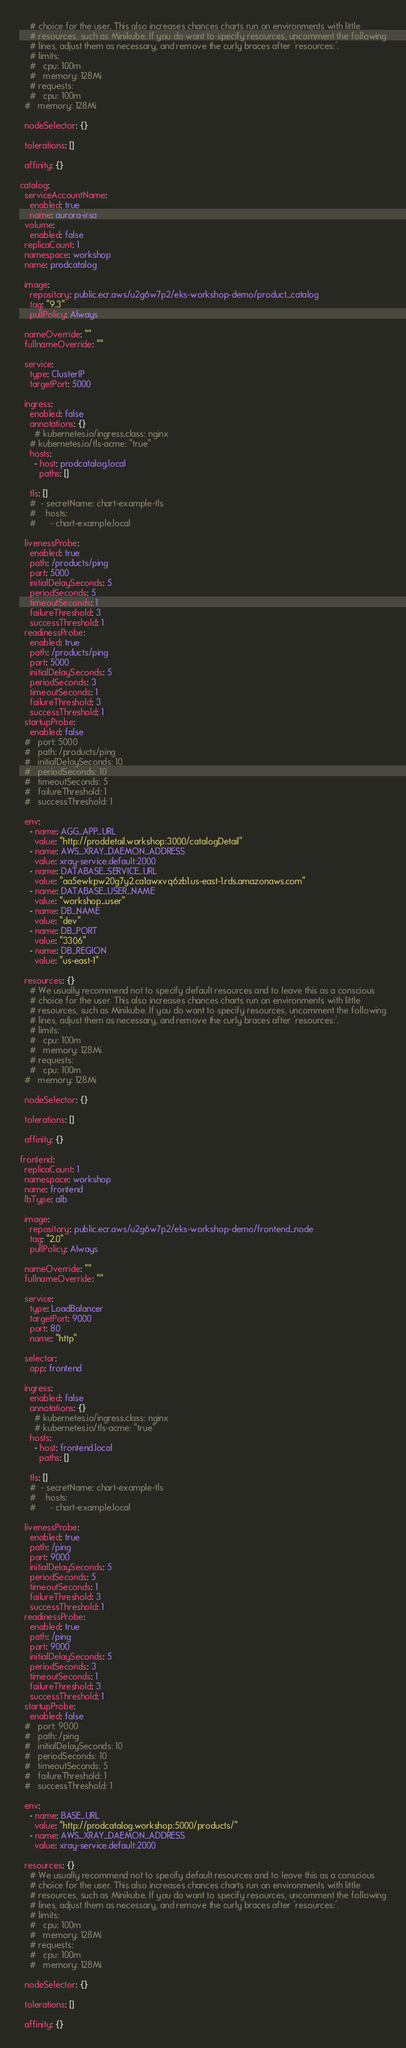<code> <loc_0><loc_0><loc_500><loc_500><_YAML_>    # choice for the user. This also increases chances charts run on environments with little
    # resources, such as Minikube. If you do want to specify resources, uncomment the following
    # lines, adjust them as necessary, and remove the curly braces after 'resources:'.
    # limits:
    #   cpu: 100m
    #   memory: 128Mi
    # requests:
    #   cpu: 100m
  #   memory: 128Mi

  nodeSelector: {}

  tolerations: []

  affinity: {}
  
catalog:
  serviceAccountName:
    enabled: true
    name: aurora-irsa
  volume:
    enabled: false
  replicaCount: 1
  namespace: workshop
  name: prodcatalog

  image:
    repository: public.ecr.aws/u2g6w7p2/eks-workshop-demo/product_catalog
    tag: "9.3"
    pullPolicy: Always

  nameOverride: ""
  fullnameOverride: ""

  service:
    type: ClusterIP
    targetPort: 5000

  ingress:
    enabled: false
    annotations: {}
      # kubernetes.io/ingress.class: nginx
    # kubernetes.io/tls-acme: "true"
    hosts:
      - host: prodcatalog.local
        paths: []

    tls: []
    #  - secretName: chart-example-tls
    #    hosts:
    #      - chart-example.local

  livenessProbe:
    enabled: true
    path: /products/ping
    port: 5000
    initialDelaySeconds: 5
    periodSeconds: 5
    timeoutSeconds: 1
    failureThreshold: 3
    successThreshold: 1
  readinessProbe:
    enabled: true
    path: /products/ping
    port: 5000
    initialDelaySeconds: 5
    periodSeconds: 3
    timeoutSeconds: 1
    failureThreshold: 3
    successThreshold: 1
  startupProbe:
    enabled: false
  #   port: 5000
  #   path: /products/ping
  #   initialDelaySeconds: 10
  #   periodSeconds: 10
  #   timeoutSeconds: 5
  #   failureThreshold: 1
  #   successThreshold: 1
    
  env:
    - name: AGG_APP_URL
      value: "http://proddetail.workshop:3000/catalogDetail"
    - name: AWS_XRAY_DAEMON_ADDRESS
      value: xray-service.default:2000
    - name: DATABASE_SERVICE_URL
      value: "aa5ewkpw20g7y2.ca1awxvq6zb1.us-east-1.rds.amazonaws.com"
    - name: DATABASE_USER_NAME
      value: "workshop_user"
    - name: DB_NAME
      value: "dev"
    - name: DB_PORT
      value: "3306"
    - name: DB_REGION
      value: "us-east-1"
      
  resources: {}
    # We usually recommend not to specify default resources and to leave this as a conscious
    # choice for the user. This also increases chances charts run on environments with little
    # resources, such as Minikube. If you do want to specify resources, uncomment the following
    # lines, adjust them as necessary, and remove the curly braces after 'resources:'.
    # limits:
    #   cpu: 100m
    #   memory: 128Mi
    # requests:
    #   cpu: 100m
  #   memory: 128Mi

  nodeSelector: {}

  tolerations: []

  affinity: {}

frontend:
  replicaCount: 1
  namespace: workshop
  name: frontend
  lbType: alb

  image:
    repository: public.ecr.aws/u2g6w7p2/eks-workshop-demo/frontend_node
    tag: "2.0"
    pullPolicy: Always

  nameOverride: ""
  fullnameOverride: ""

  service:
    type: LoadBalancer
    targetPort: 9000
    port: 80
    name: "http"

  selector:
    app: frontend

  ingress:
    enabled: false
    annotations: {}
      # kubernetes.io/ingress.class: nginx
      # kubernetes.io/tls-acme: "true"
    hosts:
      - host: frontend.local
        paths: []

    tls: []
    #  - secretName: chart-example-tls
    #    hosts:
    #      - chart-example.local

  livenessProbe:
    enabled: true
    path: /ping
    port: 9000
    initialDelaySeconds: 5
    periodSeconds: 5
    timeoutSeconds: 1
    failureThreshold: 3
    successThreshold: 1
  readinessProbe:
    enabled: true
    path: /ping
    port: 9000
    initialDelaySeconds: 5
    periodSeconds: 3
    timeoutSeconds: 1
    failureThreshold: 3
    successThreshold: 1
  startupProbe:
    enabled: false
  #   port: 9000
  #   path: /ping
  #   initialDelaySeconds: 10
  #   periodSeconds: 10
  #   timeoutSeconds: 5
  #   failureThreshold: 1
  #   successThreshold: 1
    
  env:
    - name: BASE_URL
      value: "http://prodcatalog.workshop:5000/products/"
    - name: AWS_XRAY_DAEMON_ADDRESS
      value: xray-service.default:2000
    
  resources: {}
    # We usually recommend not to specify default resources and to leave this as a conscious
    # choice for the user. This also increases chances charts run on environments with little
    # resources, such as Minikube. If you do want to specify resources, uncomment the following
    # lines, adjust them as necessary, and remove the curly braces after 'resources:'.
    # limits:
    #   cpu: 100m
    #   memory: 128Mi
    # requests:
    #   cpu: 100m
    #   memory: 128Mi

  nodeSelector: {}

  tolerations: []

  affinity: {}
</code> 